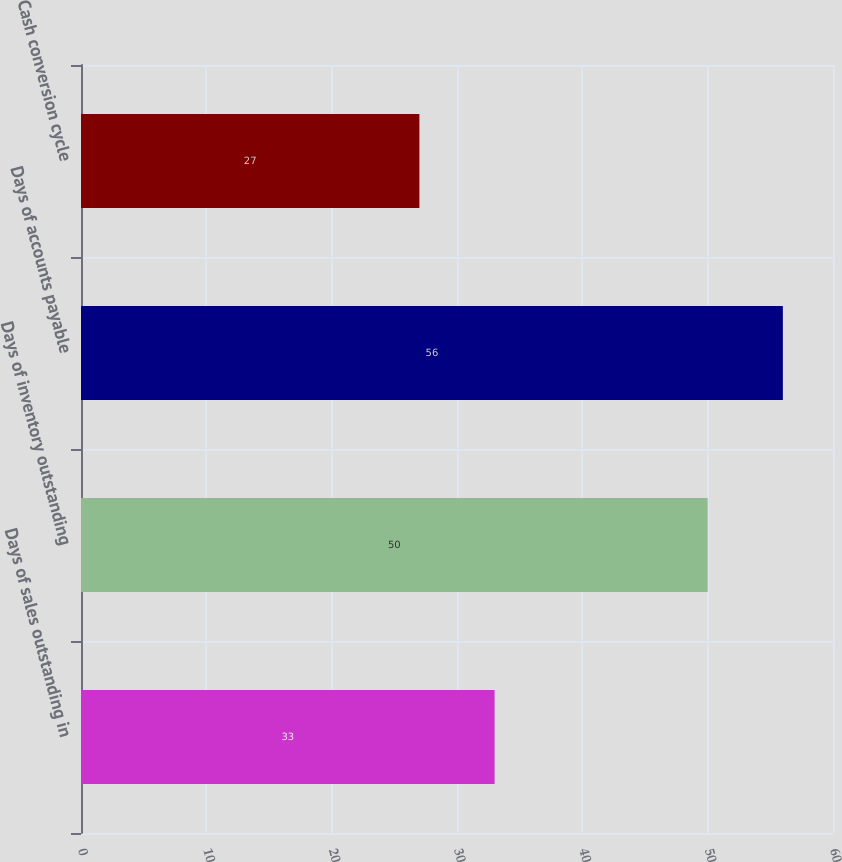Convert chart to OTSL. <chart><loc_0><loc_0><loc_500><loc_500><bar_chart><fcel>Days of sales outstanding in<fcel>Days of inventory outstanding<fcel>Days of accounts payable<fcel>Cash conversion cycle<nl><fcel>33<fcel>50<fcel>56<fcel>27<nl></chart> 